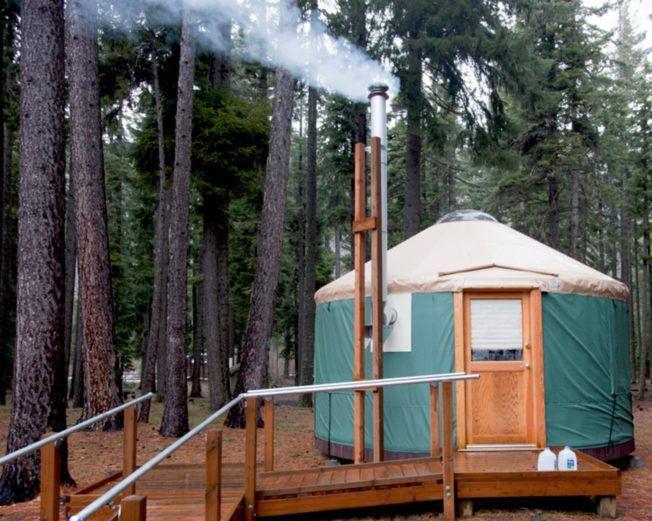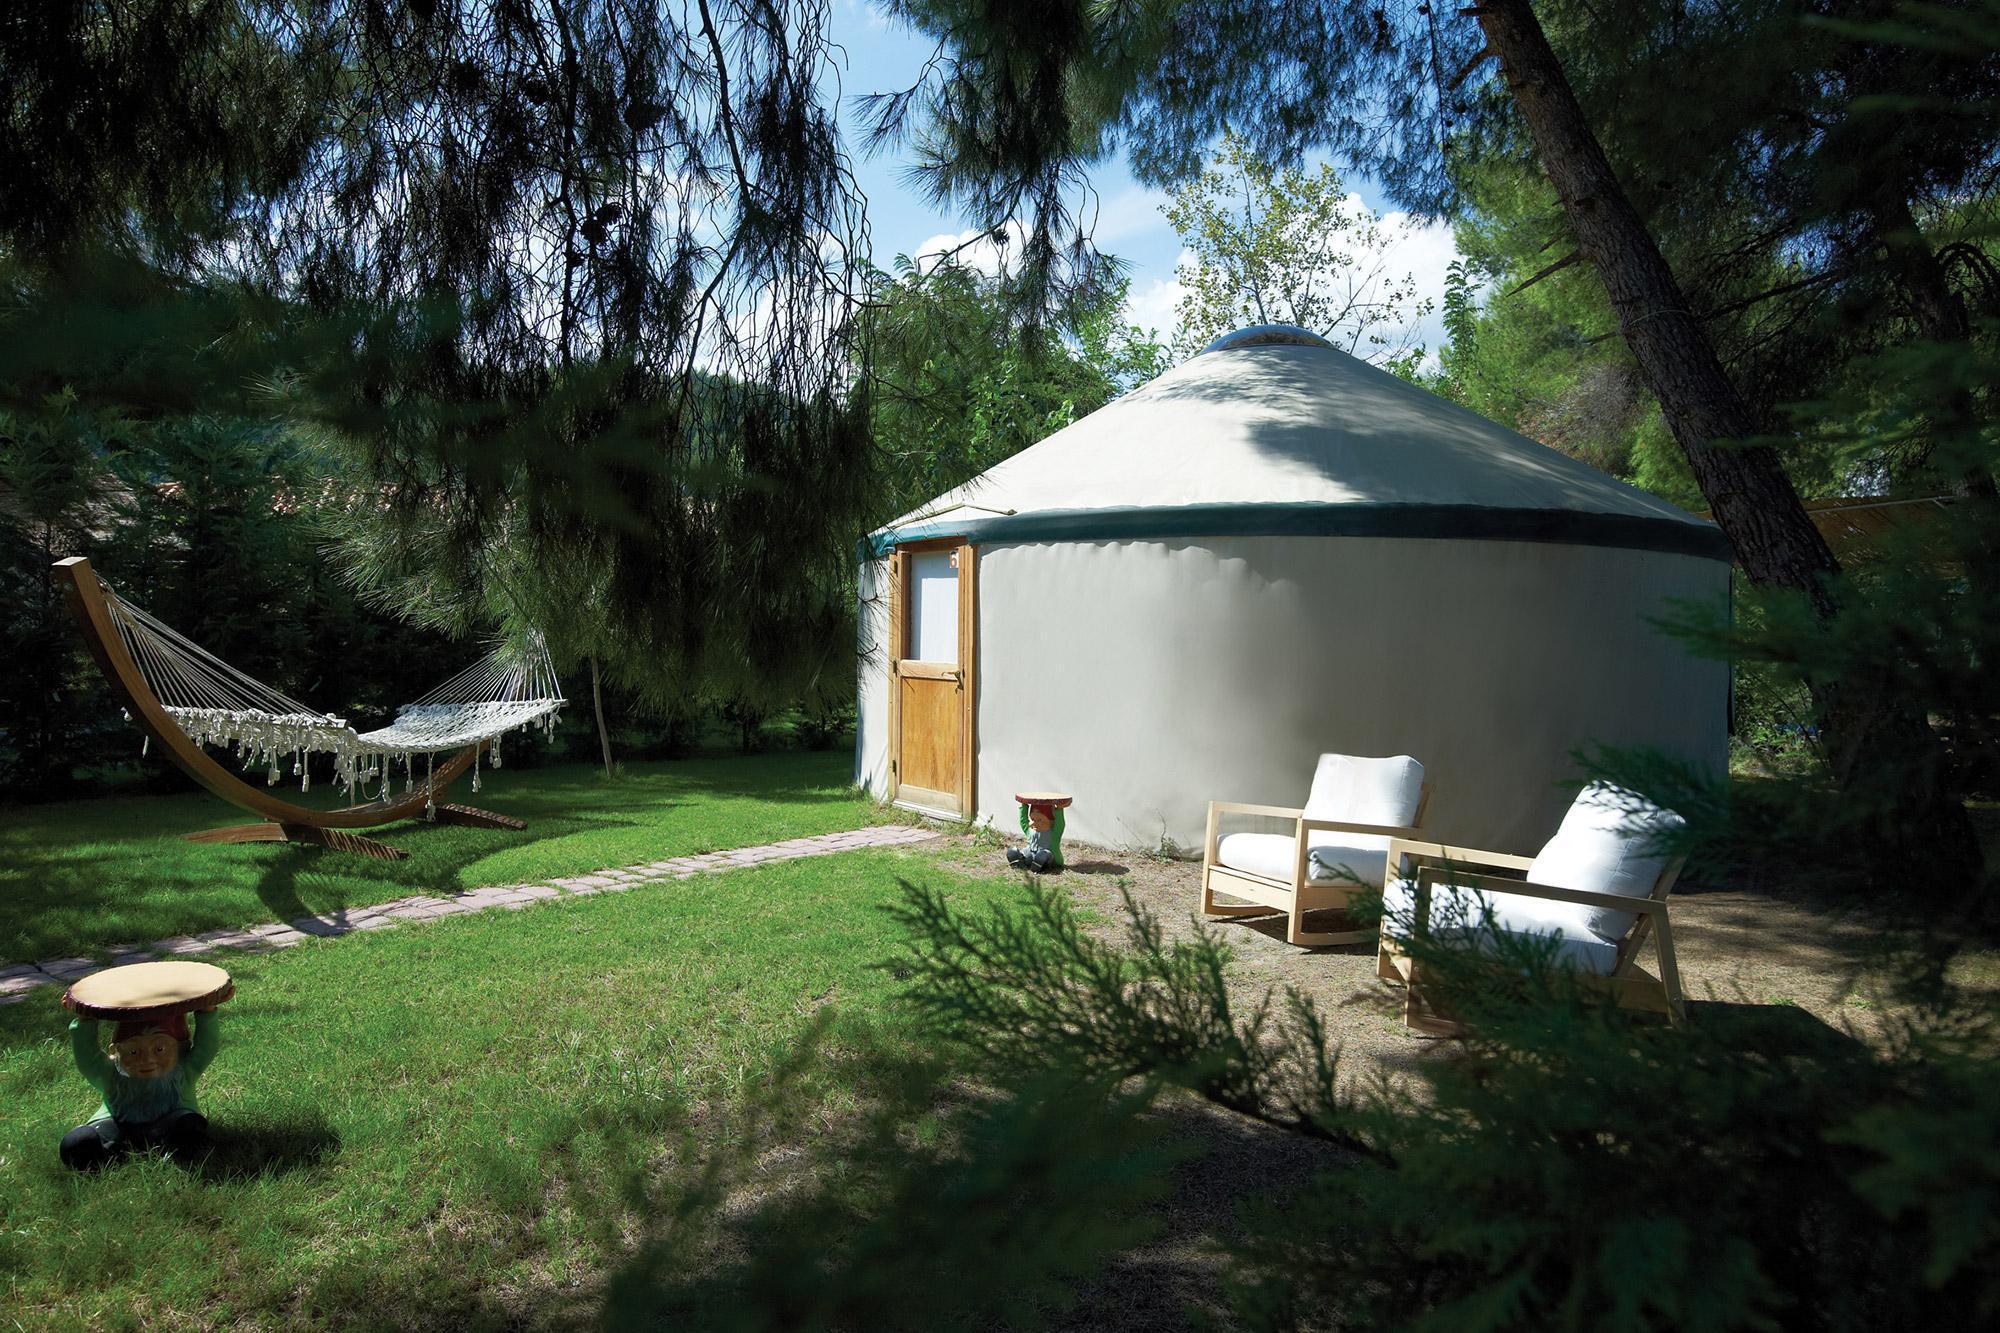The first image is the image on the left, the second image is the image on the right. Considering the images on both sides, is "An interior and an exterior image of a round house are shown." valid? Answer yes or no. No. 